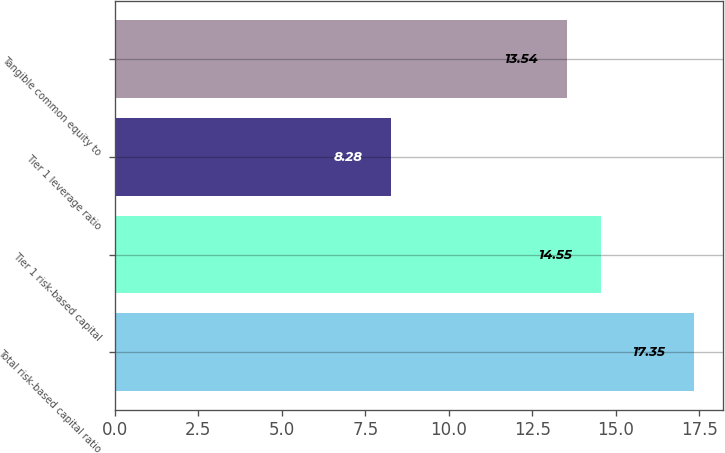Convert chart to OTSL. <chart><loc_0><loc_0><loc_500><loc_500><bar_chart><fcel>Total risk-based capital ratio<fcel>Tier 1 risk-based capital<fcel>Tier 1 leverage ratio<fcel>Tangible common equity to<nl><fcel>17.35<fcel>14.55<fcel>8.28<fcel>13.54<nl></chart> 